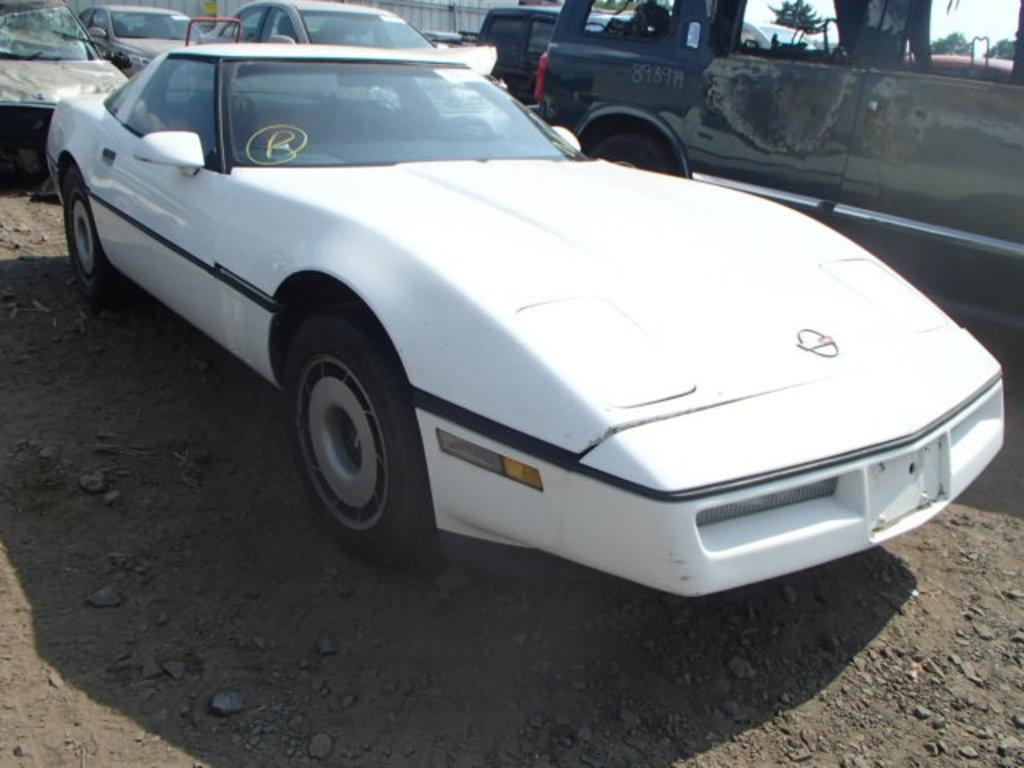Please provide a concise description of this image. In this image we can see a white color car. Behind so many cars are there. 